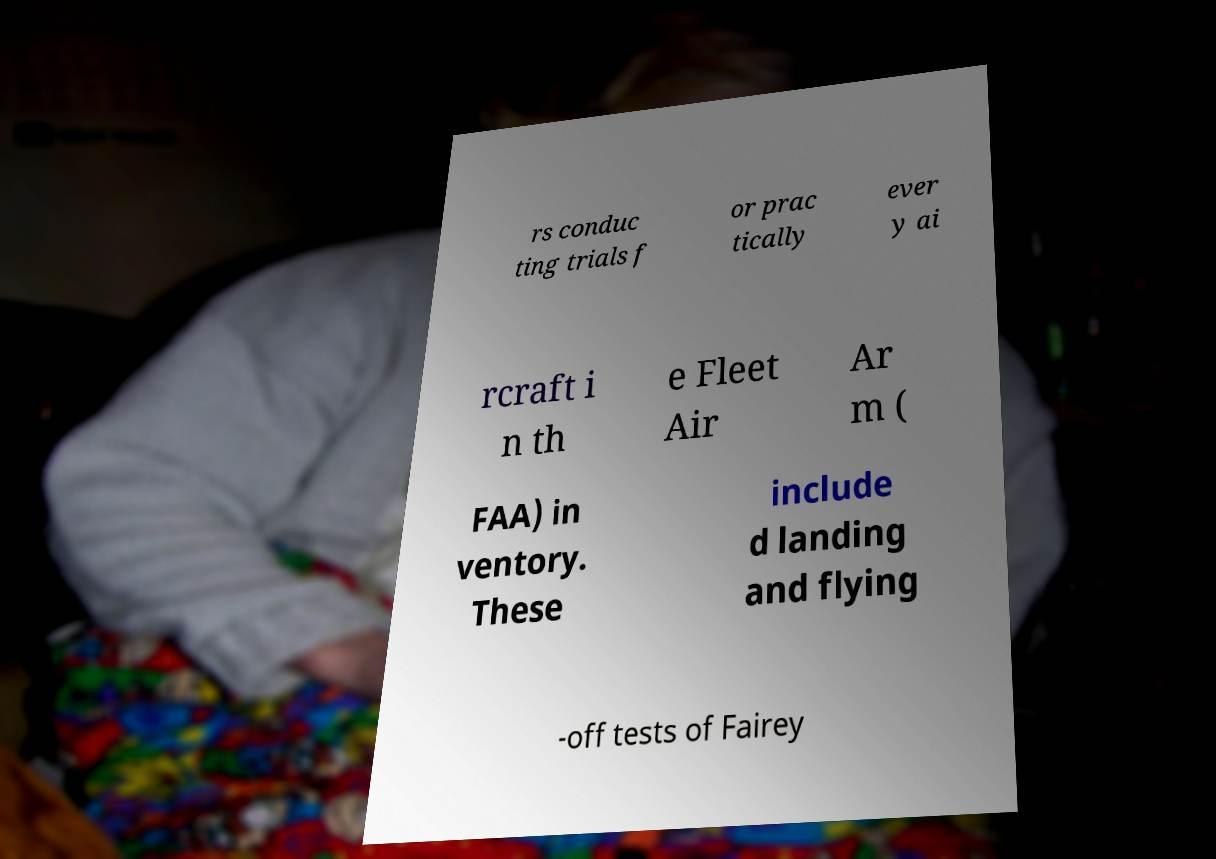I need the written content from this picture converted into text. Can you do that? rs conduc ting trials f or prac tically ever y ai rcraft i n th e Fleet Air Ar m ( FAA) in ventory. These include d landing and flying -off tests of Fairey 